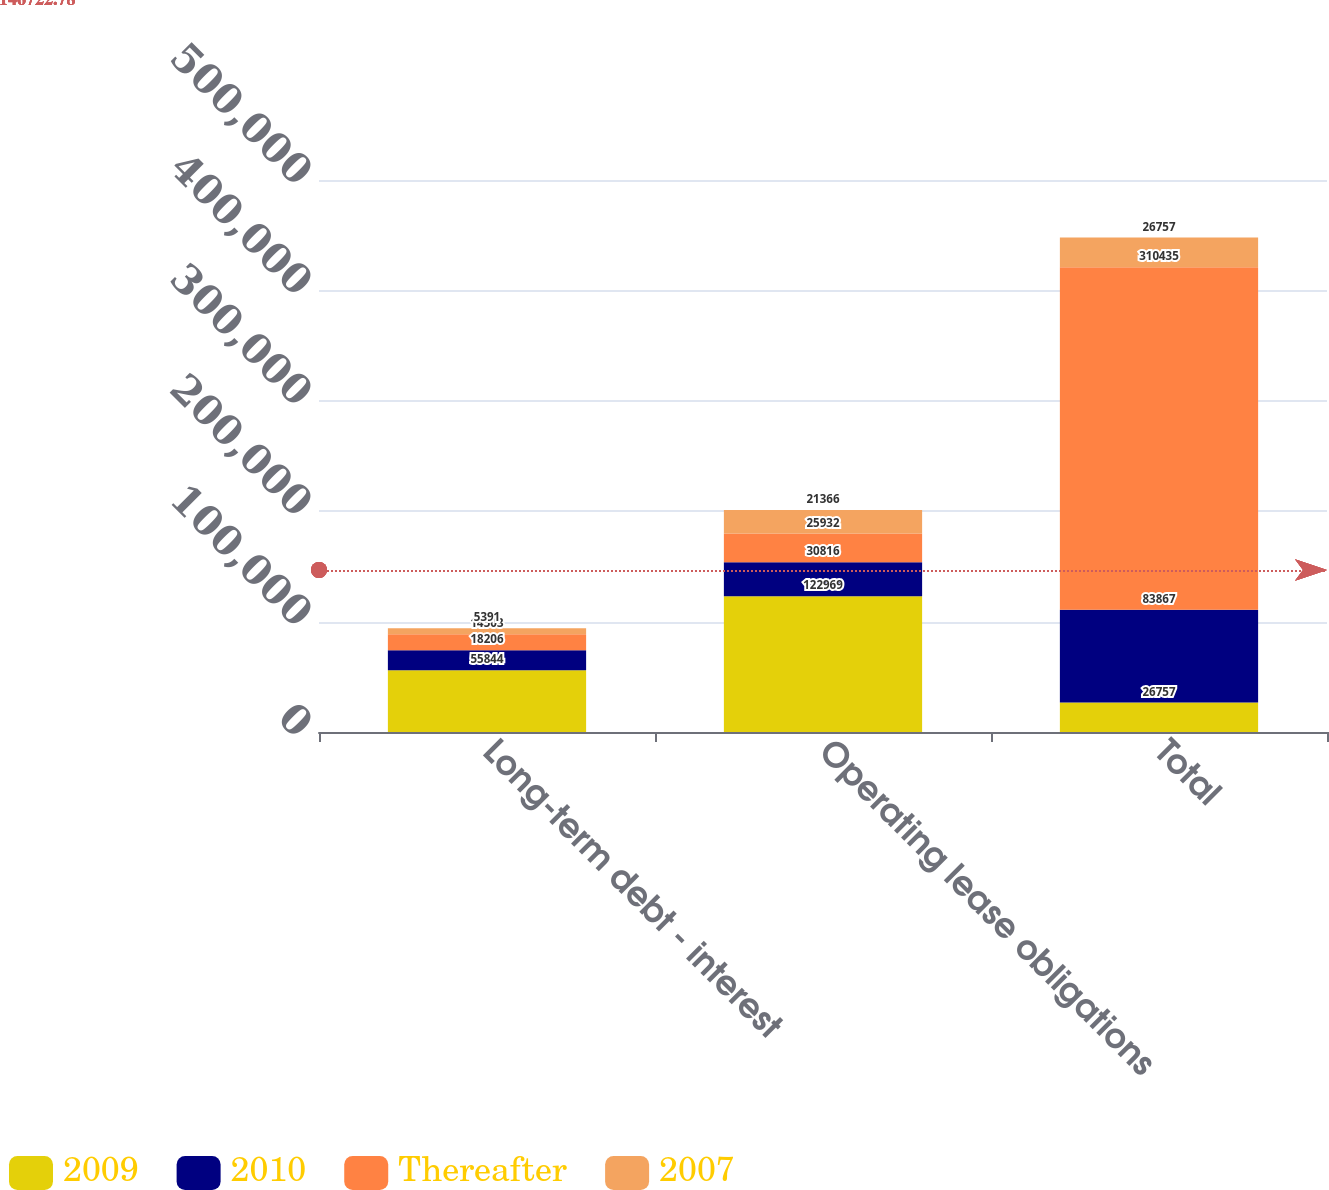Convert chart. <chart><loc_0><loc_0><loc_500><loc_500><stacked_bar_chart><ecel><fcel>Long-term debt - interest<fcel>Operating lease obligations<fcel>Total<nl><fcel>2009<fcel>55844<fcel>122969<fcel>26757<nl><fcel>2010<fcel>18206<fcel>30816<fcel>83867<nl><fcel>Thereafter<fcel>14503<fcel>25932<fcel>310435<nl><fcel>2007<fcel>5391<fcel>21366<fcel>26757<nl></chart> 